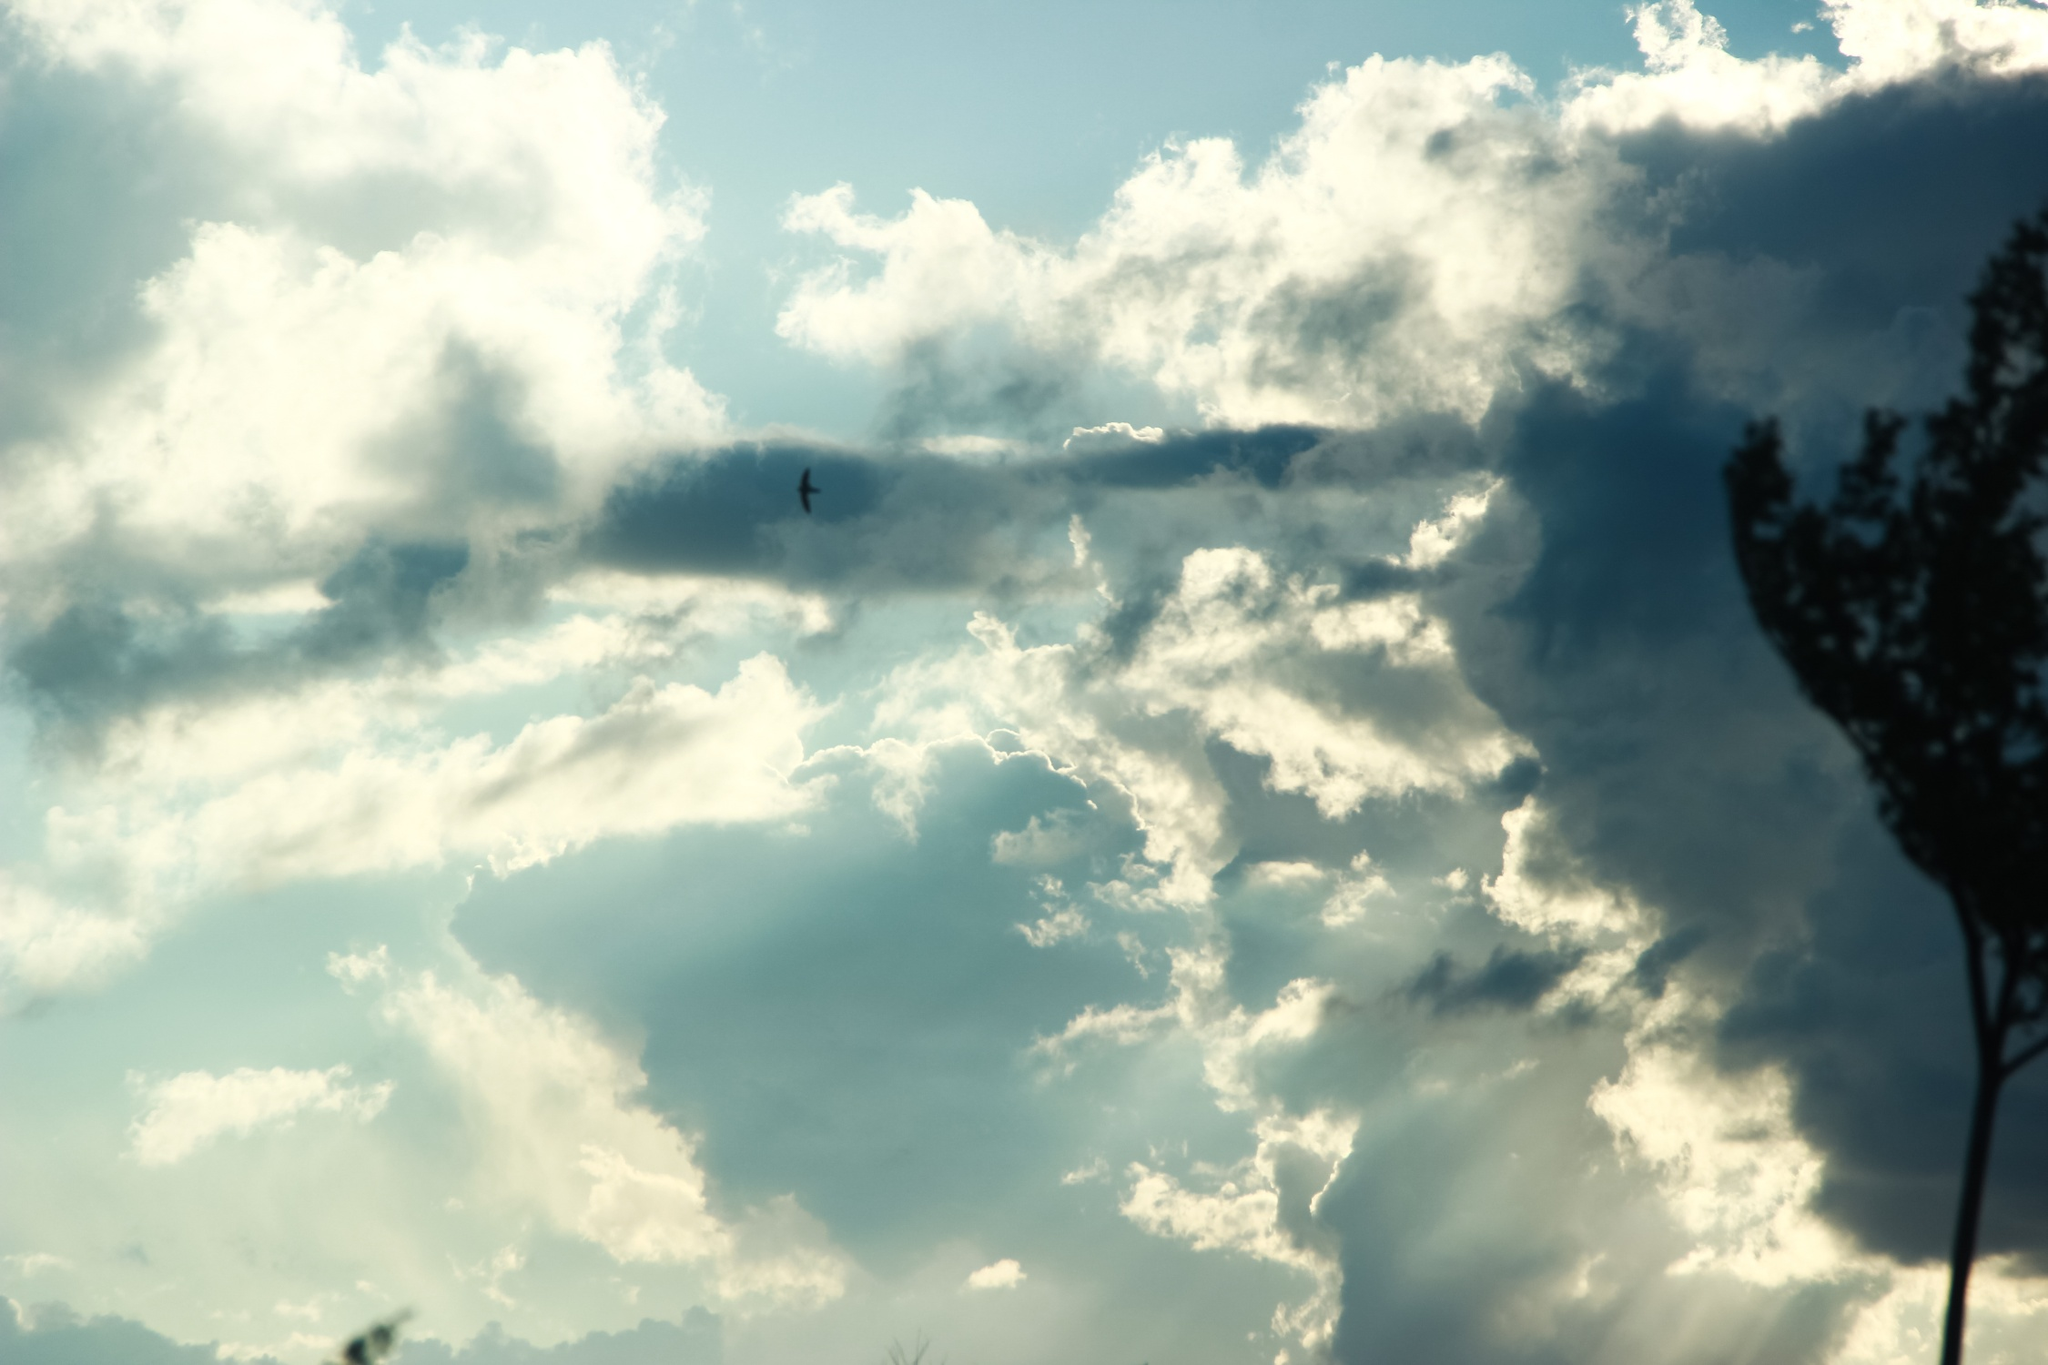What could this tree have witnessed over the years? This ancient, resilient tree has stood as a silent observer to the passage of time. It has seen countless sunrises and sunsets, each painting the sky with hues of gold and crimson. The tree has weathered fierce storms and gentle rains, its roots digging deeper into the earth with every passing year. Animals have sought shelter under its branches, generations of birds have built nests and raised their young here. It has borne witness to changing seasons, from the vibrant greens of spring to the bare branches of winter. In the quiet nights, the tree has stood under the watchful gaze of the stars, telling tales of constellations and cosmic wonders to those who would listen. This tree has shared the dreams of wanderers, the secrets of lovers, and the stories of countless lives that have come and gone. 